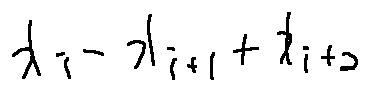<formula> <loc_0><loc_0><loc_500><loc_500>x _ { i } - x _ { i + 1 } + x _ { i + 2 }</formula> 